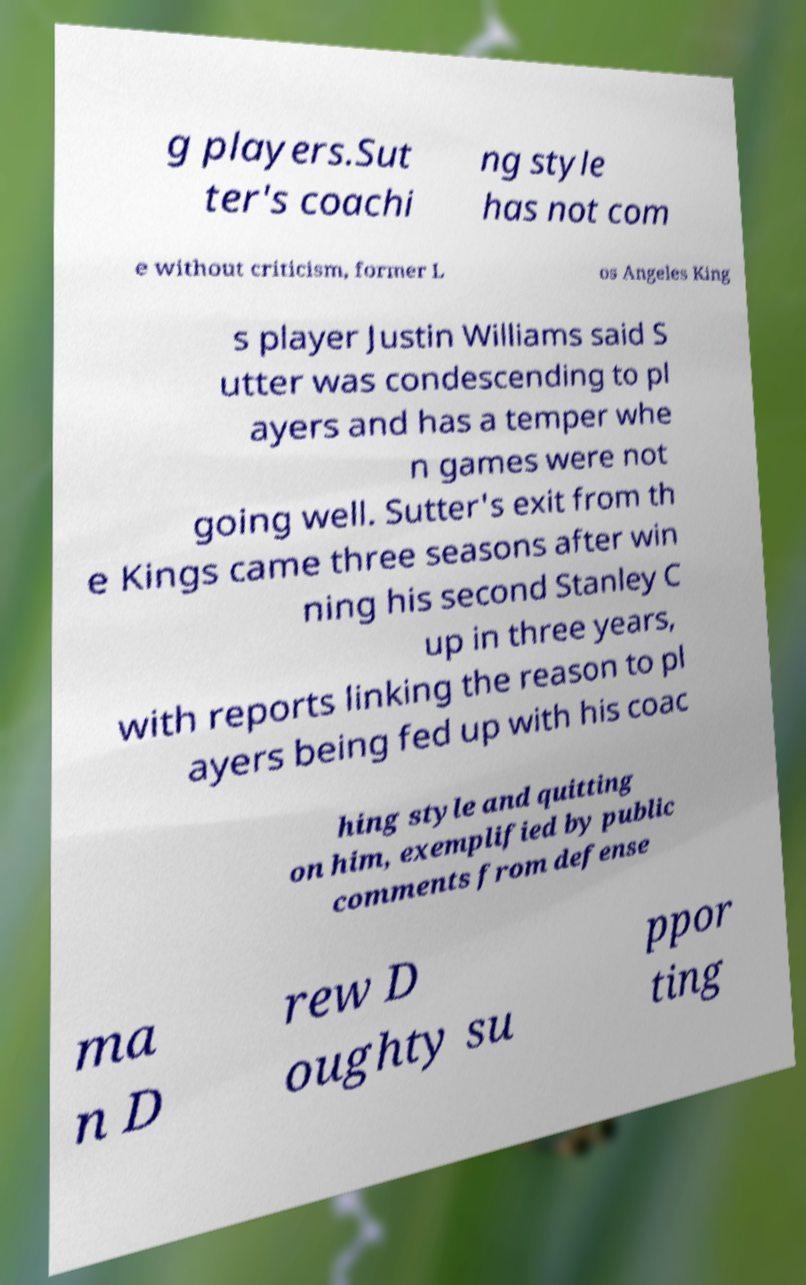For documentation purposes, I need the text within this image transcribed. Could you provide that? g players.Sut ter's coachi ng style has not com e without criticism, former L os Angeles King s player Justin Williams said S utter was condescending to pl ayers and has a temper whe n games were not going well. Sutter's exit from th e Kings came three seasons after win ning his second Stanley C up in three years, with reports linking the reason to pl ayers being fed up with his coac hing style and quitting on him, exemplified by public comments from defense ma n D rew D oughty su ppor ting 